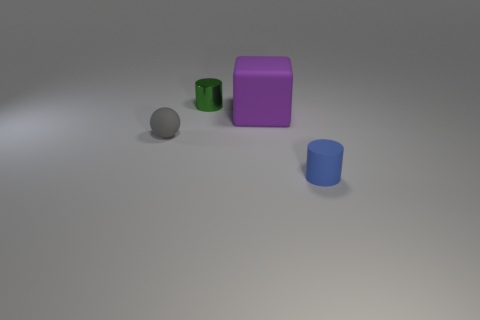Add 4 metal objects. How many objects exist? 8 Subtract all balls. How many objects are left? 3 Add 1 large things. How many large things are left? 2 Add 3 small metallic cylinders. How many small metallic cylinders exist? 4 Subtract 0 green blocks. How many objects are left? 4 Subtract all blue shiny cubes. Subtract all gray matte balls. How many objects are left? 3 